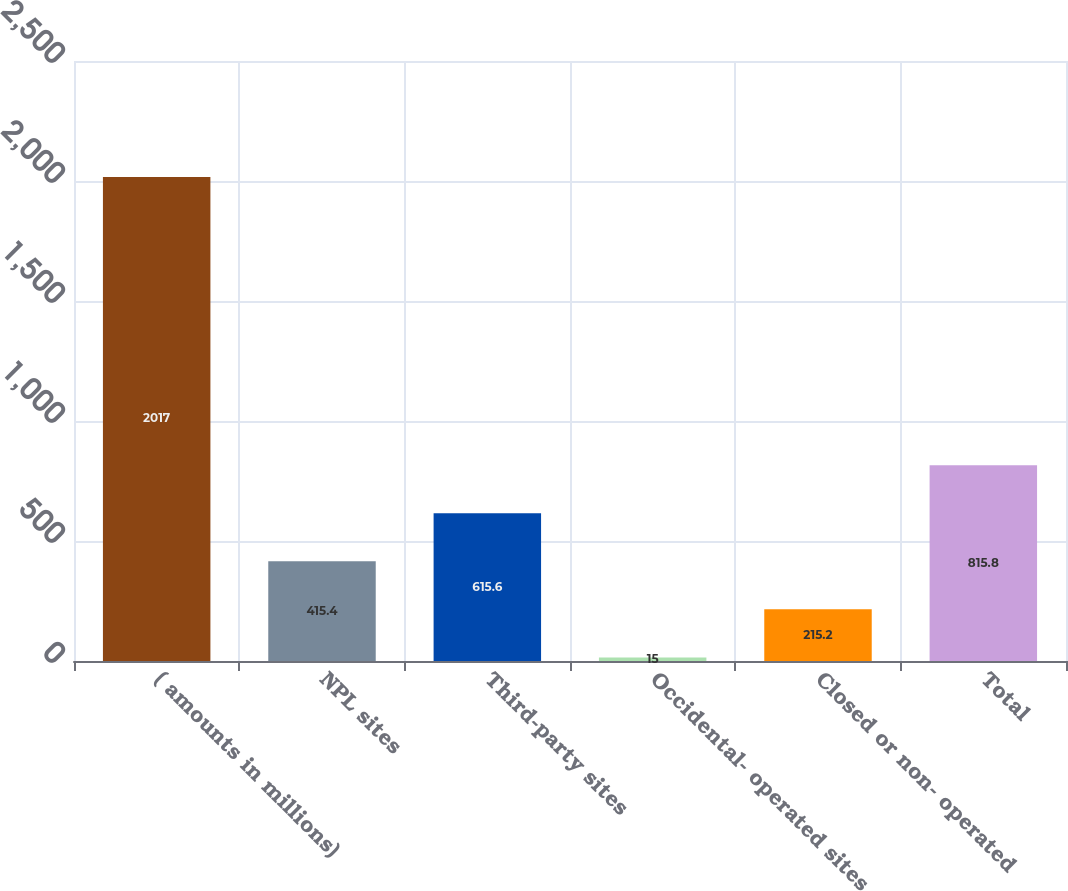<chart> <loc_0><loc_0><loc_500><loc_500><bar_chart><fcel>( amounts in millions)<fcel>NPL sites<fcel>Third-party sites<fcel>Occidental- operated sites<fcel>Closed or non- operated<fcel>Total<nl><fcel>2017<fcel>415.4<fcel>615.6<fcel>15<fcel>215.2<fcel>815.8<nl></chart> 